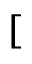Convert formula to latex. <formula><loc_0><loc_0><loc_500><loc_500>[</formula> 